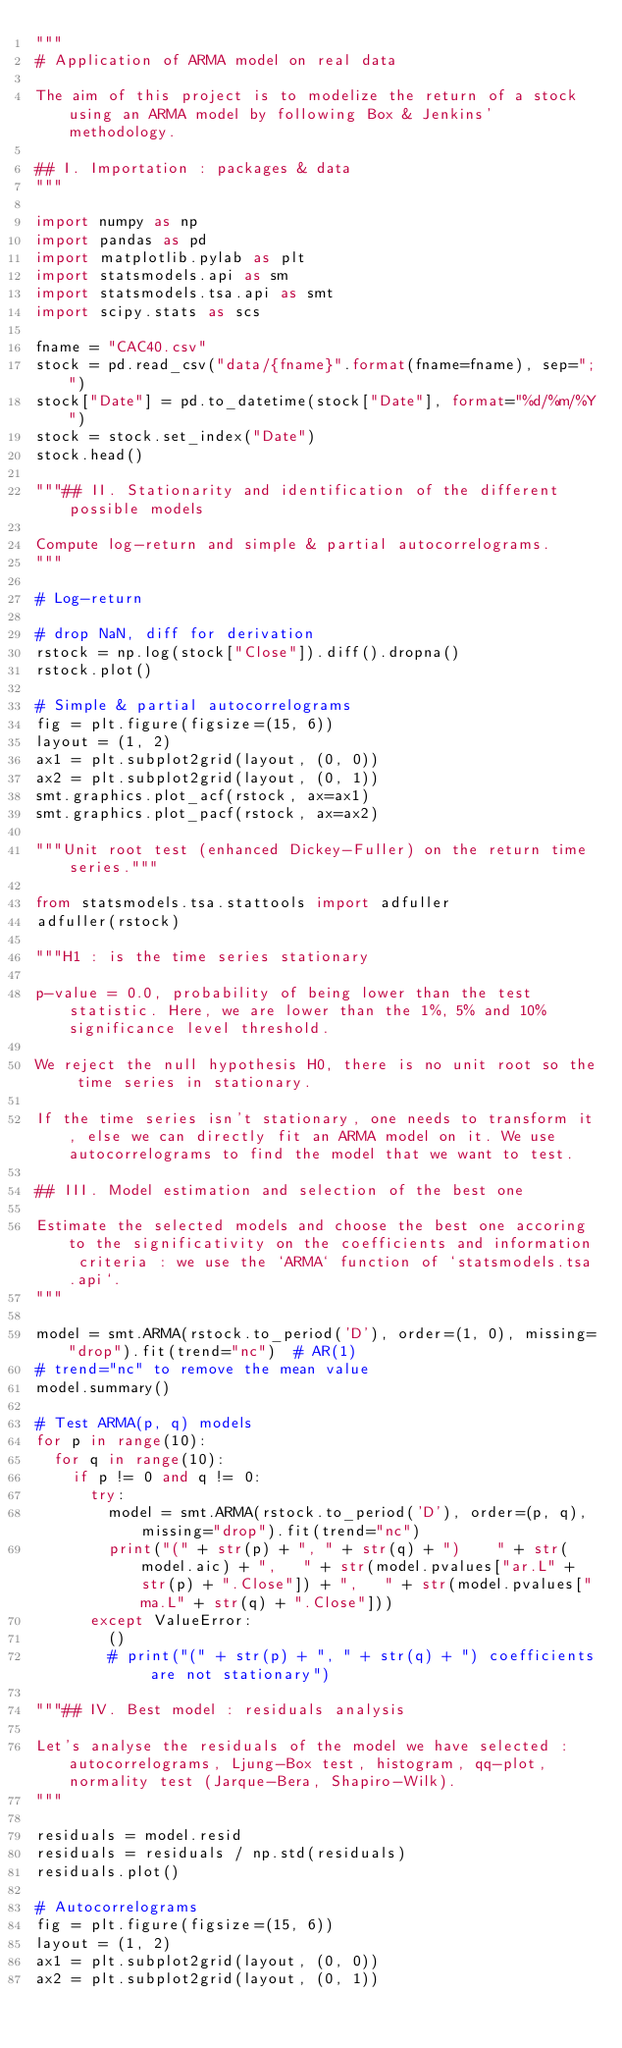<code> <loc_0><loc_0><loc_500><loc_500><_Python_>"""
# Application of ARMA model on real data

The aim of this project is to modelize the return of a stock using an ARMA model by following Box & Jenkins' methodology.

## I. Importation : packages & data
"""

import numpy as np
import pandas as pd
import matplotlib.pylab as plt
import statsmodels.api as sm
import statsmodels.tsa.api as smt
import scipy.stats as scs

fname = "CAC40.csv"
stock = pd.read_csv("data/{fname}".format(fname=fname), sep=";")
stock["Date"] = pd.to_datetime(stock["Date"], format="%d/%m/%Y")
stock = stock.set_index("Date")
stock.head()

"""## II. Stationarity and identification of the different possible models

Compute log-return and simple & partial autocorrelograms.
"""

# Log-return

# drop NaN, diff for derivation
rstock = np.log(stock["Close"]).diff().dropna()
rstock.plot()

# Simple & partial autocorrelograms
fig = plt.figure(figsize=(15, 6))
layout = (1, 2)
ax1 = plt.subplot2grid(layout, (0, 0))
ax2 = plt.subplot2grid(layout, (0, 1))
smt.graphics.plot_acf(rstock, ax=ax1)
smt.graphics.plot_pacf(rstock, ax=ax2)

"""Unit root test (enhanced Dickey-Fuller) on the return time series."""

from statsmodels.tsa.stattools import adfuller
adfuller(rstock)

"""H1 : is the time series stationary

p-value = 0.0, probability of being lower than the test statistic. Here, we are lower than the 1%, 5% and 10% significance level threshold.

We reject the null hypothesis H0, there is no unit root so the time series in stationary.

If the time series isn't stationary, one needs to transform it, else we can directly fit an ARMA model on it. We use autocorrelograms to find the model that we want to test.

## III. Model estimation and selection of the best one

Estimate the selected models and choose the best one accoring to the significativity on the coefficients and information criteria : we use the `ARMA` function of `statsmodels.tsa.api`.
"""

model = smt.ARMA(rstock.to_period('D'), order=(1, 0), missing="drop").fit(trend="nc")  # AR(1)
# trend="nc" to remove the mean value
model.summary()

# Test ARMA(p, q) models
for p in range(10):
  for q in range(10):
    if p != 0 and q != 0:
      try:
        model = smt.ARMA(rstock.to_period('D'), order=(p, q), missing="drop").fit(trend="nc")
        print("(" + str(p) + ", " + str(q) + ")    " + str(model.aic) + ",   " + str(model.pvalues["ar.L" + str(p) + ".Close"]) + ",   " + str(model.pvalues["ma.L" + str(q) + ".Close"]))
      except ValueError:
        ()
        # print("(" + str(p) + ", " + str(q) + ") coefficients are not stationary")

"""## IV. Best model : residuals analysis

Let's analyse the residuals of the model we have selected : autocorrelograms, Ljung-Box test, histogram, qq-plot, normality test (Jarque-Bera, Shapiro-Wilk).
"""

residuals = model.resid
residuals = residuals / np.std(residuals)
residuals.plot()

# Autocorrelograms
fig = plt.figure(figsize=(15, 6))
layout = (1, 2)
ax1 = plt.subplot2grid(layout, (0, 0))
ax2 = plt.subplot2grid(layout, (0, 1))</code> 